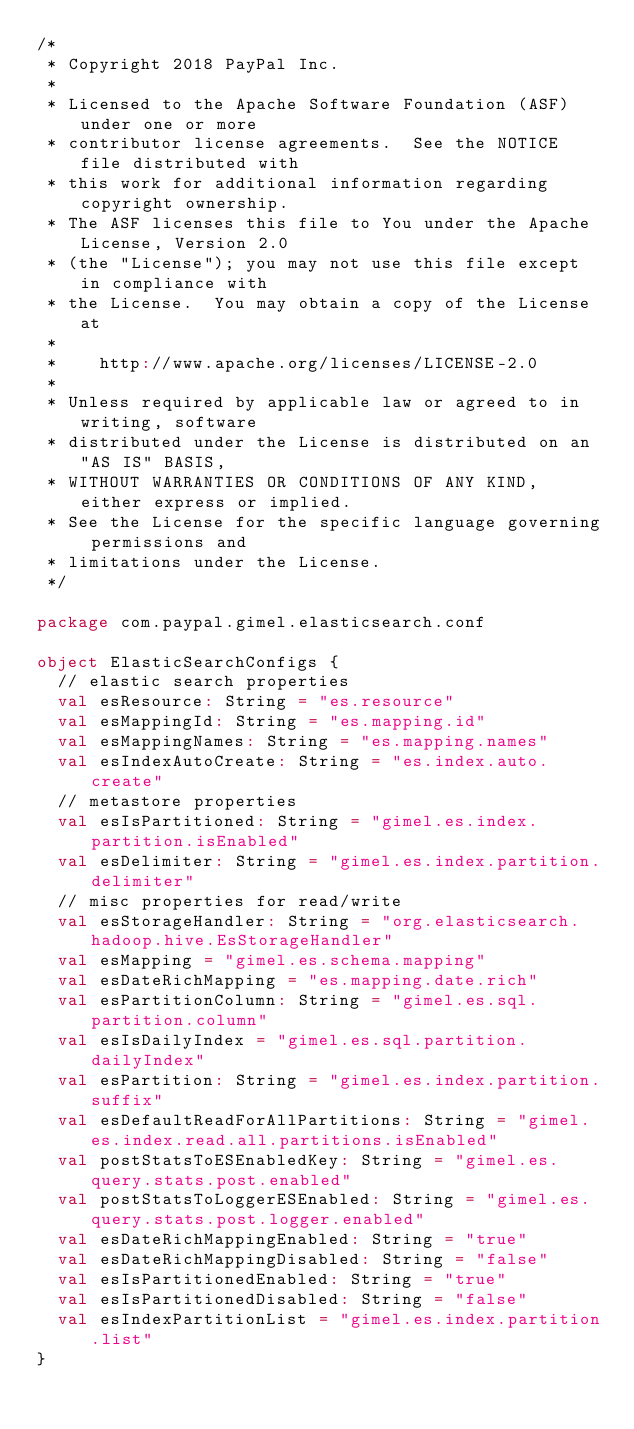Convert code to text. <code><loc_0><loc_0><loc_500><loc_500><_Scala_>/*
 * Copyright 2018 PayPal Inc.
 *
 * Licensed to the Apache Software Foundation (ASF) under one or more
 * contributor license agreements.  See the NOTICE file distributed with
 * this work for additional information regarding copyright ownership.
 * The ASF licenses this file to You under the Apache License, Version 2.0
 * (the "License"); you may not use this file except in compliance with
 * the License.  You may obtain a copy of the License at
 *
 *    http://www.apache.org/licenses/LICENSE-2.0
 *
 * Unless required by applicable law or agreed to in writing, software
 * distributed under the License is distributed on an "AS IS" BASIS,
 * WITHOUT WARRANTIES OR CONDITIONS OF ANY KIND, either express or implied.
 * See the License for the specific language governing permissions and
 * limitations under the License.
 */

package com.paypal.gimel.elasticsearch.conf

object ElasticSearchConfigs {
  // elastic search properties
  val esResource: String = "es.resource"
  val esMappingId: String = "es.mapping.id"
  val esMappingNames: String = "es.mapping.names"
  val esIndexAutoCreate: String = "es.index.auto.create"
  // metastore properties
  val esIsPartitioned: String = "gimel.es.index.partition.isEnabled"
  val esDelimiter: String = "gimel.es.index.partition.delimiter"
  // misc properties for read/write
  val esStorageHandler: String = "org.elasticsearch.hadoop.hive.EsStorageHandler"
  val esMapping = "gimel.es.schema.mapping"
  val esDateRichMapping = "es.mapping.date.rich"
  val esPartitionColumn: String = "gimel.es.sql.partition.column"
  val esIsDailyIndex = "gimel.es.sql.partition.dailyIndex"
  val esPartition: String = "gimel.es.index.partition.suffix"
  val esDefaultReadForAllPartitions: String = "gimel.es.index.read.all.partitions.isEnabled"
  val postStatsToESEnabledKey: String = "gimel.es.query.stats.post.enabled"
  val postStatsToLoggerESEnabled: String = "gimel.es.query.stats.post.logger.enabled"
  val esDateRichMappingEnabled: String = "true"
  val esDateRichMappingDisabled: String = "false"
  val esIsPartitionedEnabled: String = "true"
  val esIsPartitionedDisabled: String = "false"
  val esIndexPartitionList = "gimel.es.index.partition.list"
}

</code> 